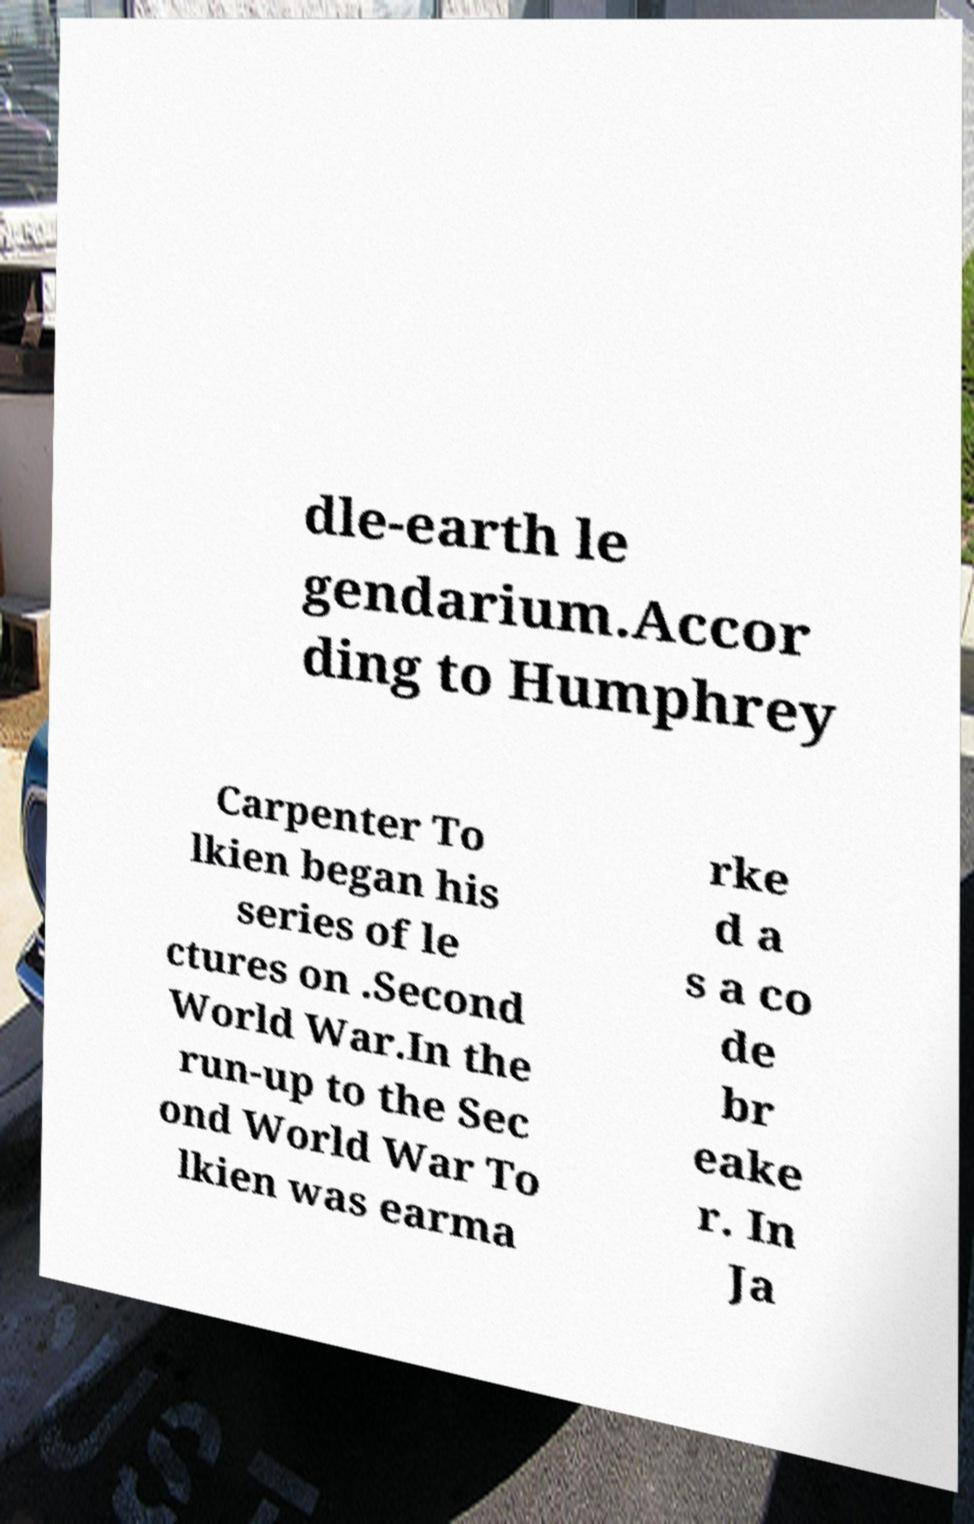Please read and relay the text visible in this image. What does it say? dle-earth le gendarium.Accor ding to Humphrey Carpenter To lkien began his series of le ctures on .Second World War.In the run-up to the Sec ond World War To lkien was earma rke d a s a co de br eake r. In Ja 